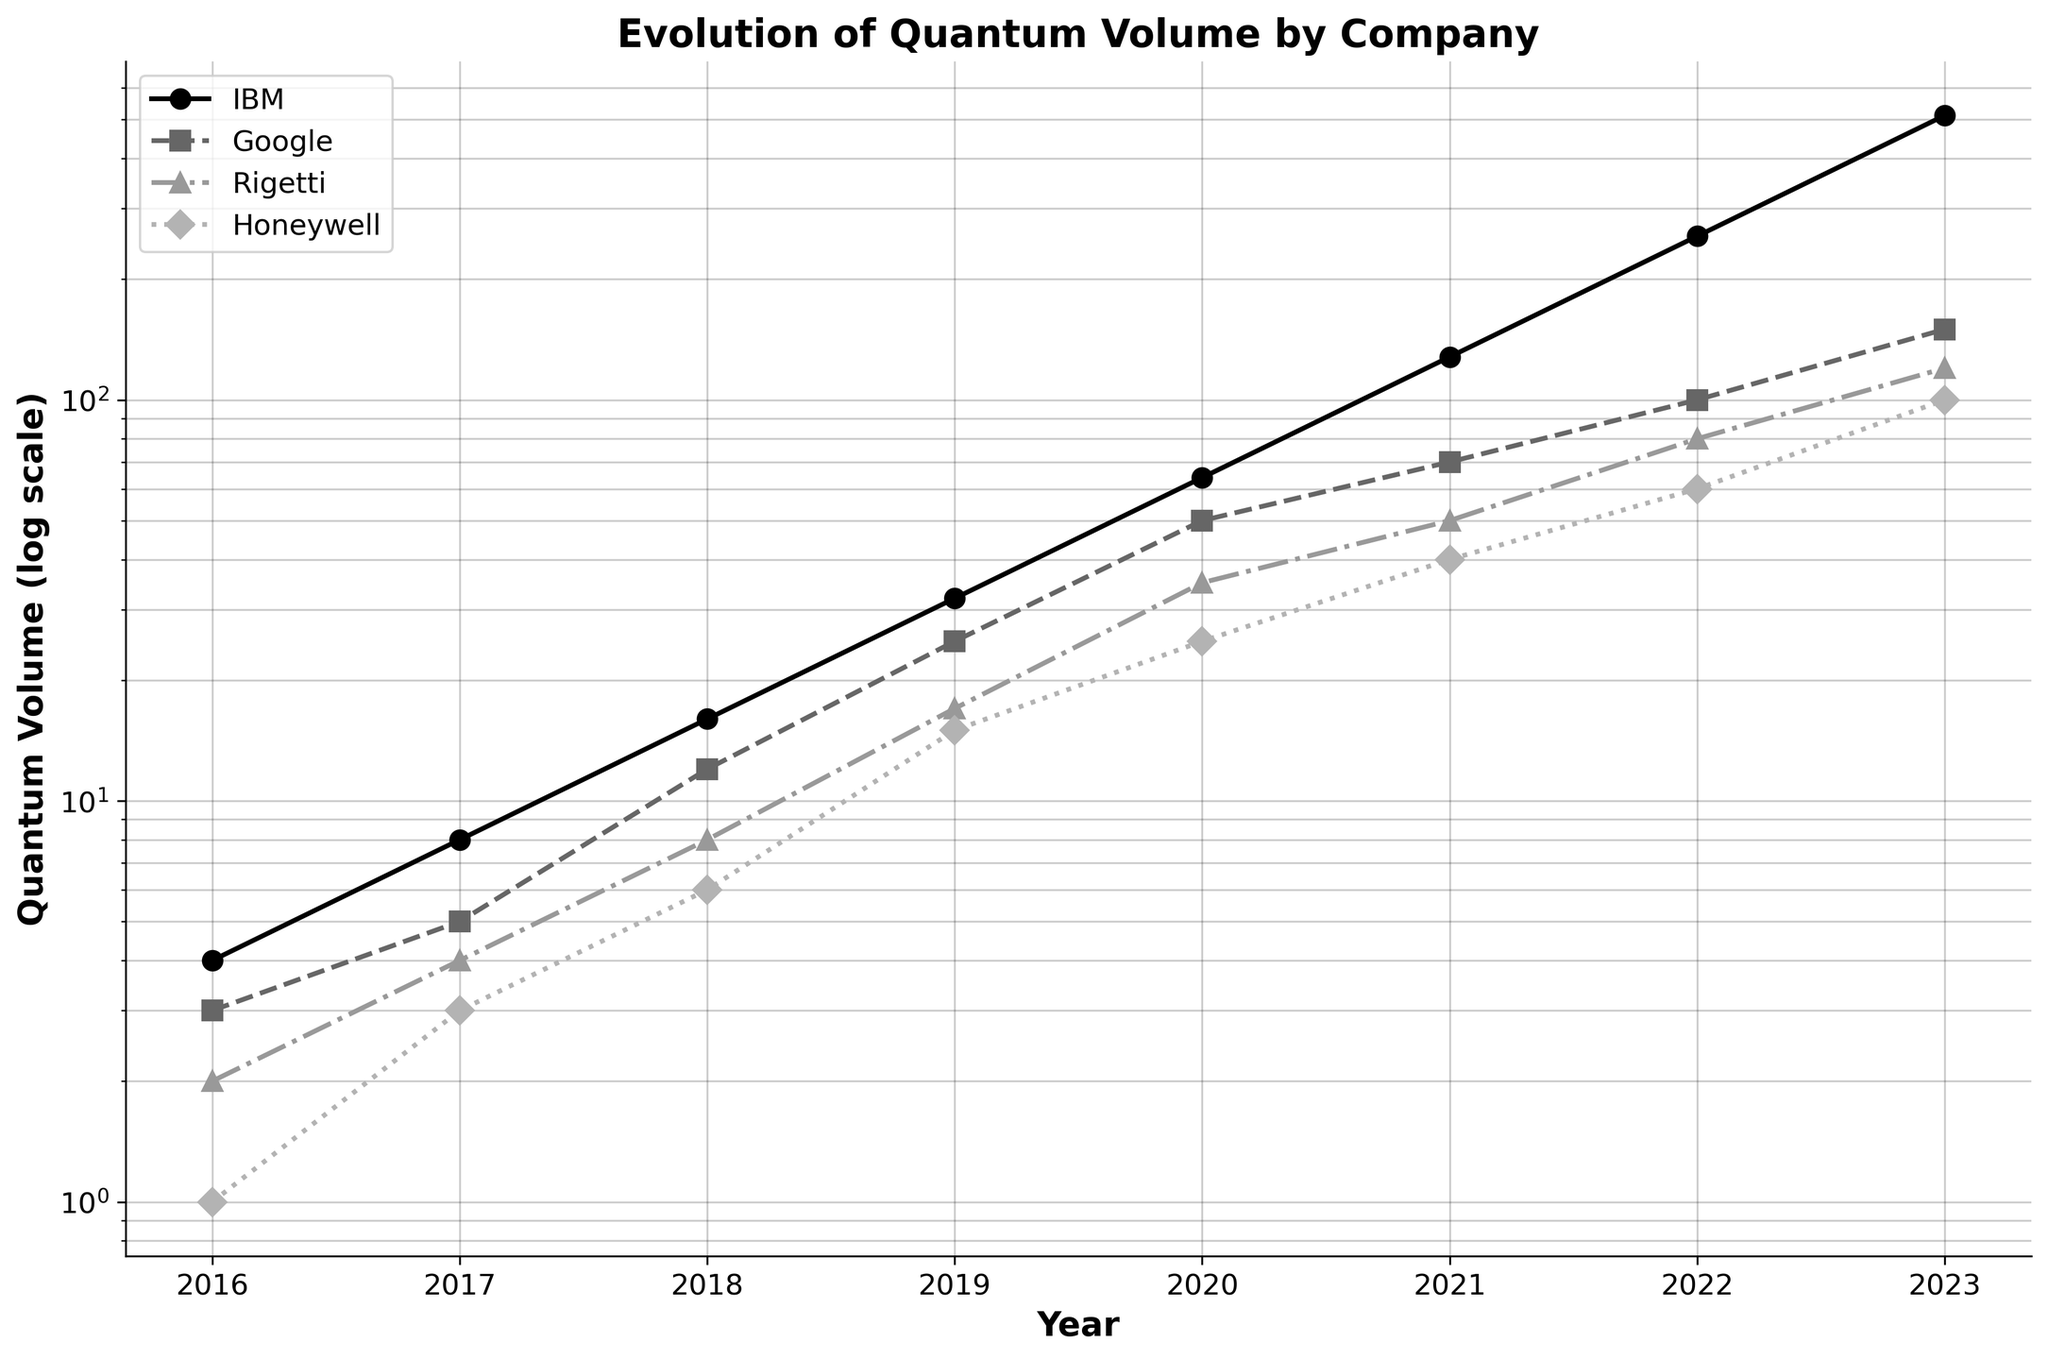What is the title of the figure? The title of the figure is displayed at the top and is usually the most prominent text in the figure, designed to summarize the main subject. In this case, it reads "Evolution of Quantum Volume by Company."
Answer: Evolution of Quantum Volume by Company Which company shows the highest quantum volume in 2023? Looking at the data points for 2023 in the plot, IBM's quantum volume reaches the highest value among all companies.
Answer: IBM How many companies are represented in this figure? To determine the number of companies, we can count the unique lines and markers in the plot legend. The legend shows four companies.
Answer: 4 Which company had the smallest quantum volume in 2018 and what was its value? By referring to the data points for 2018, Honeywell had the smallest quantum volume as indicated by the lowest point among all companies for that year. The value is 6.
Answer: Honeywell, 6 What is the trend in IBM's quantum volume from 2016 to 2023? Observing the line marked for IBM, we notice that its quantum volume increases exponentially over the years, showing an upward trend each year.
Answer: Upward trend What is the difference between Google’s and Rigetti’s quantum volume in 2020? By examining the quantum volume values for Google and Rigetti in 2020, we subtract Rigetti's value (35) from Google's value (50) to find the difference. 50 - 35 = 15.
Answer: 15 How does Honeywell's quantum volume in 2019 compare to its quantum volume in 2016? Comparing the two data points for Honeywell (2016: 1, 2019: 15), we can see that it significantly increased over the three-year period.
Answer: Increased Which company shows the most significant growth in quantum volume between 2016 and 2023? Specifically looking at the starting and ending data points of each company, IBM shows the most significant growth, from 4 in 2016 to 512 in 2023, a 128x increase.
Answer: IBM Arrange the companies based on their quantum volume in 2021 from highest to lowest. By comparing the data points for all companies in 2021, we can rank them as follows: IBM (128), Google (70), Rigetti (50), Honeywell (40).
Answer: IBM, Google, Rigetti, Honeywell Is there any year where two companies have the same quantum volume? Examining each year, there is no instance where any two companies have exactly the same quantum volume.
Answer: No 